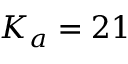Convert formula to latex. <formula><loc_0><loc_0><loc_500><loc_500>K _ { a } = 2 1</formula> 